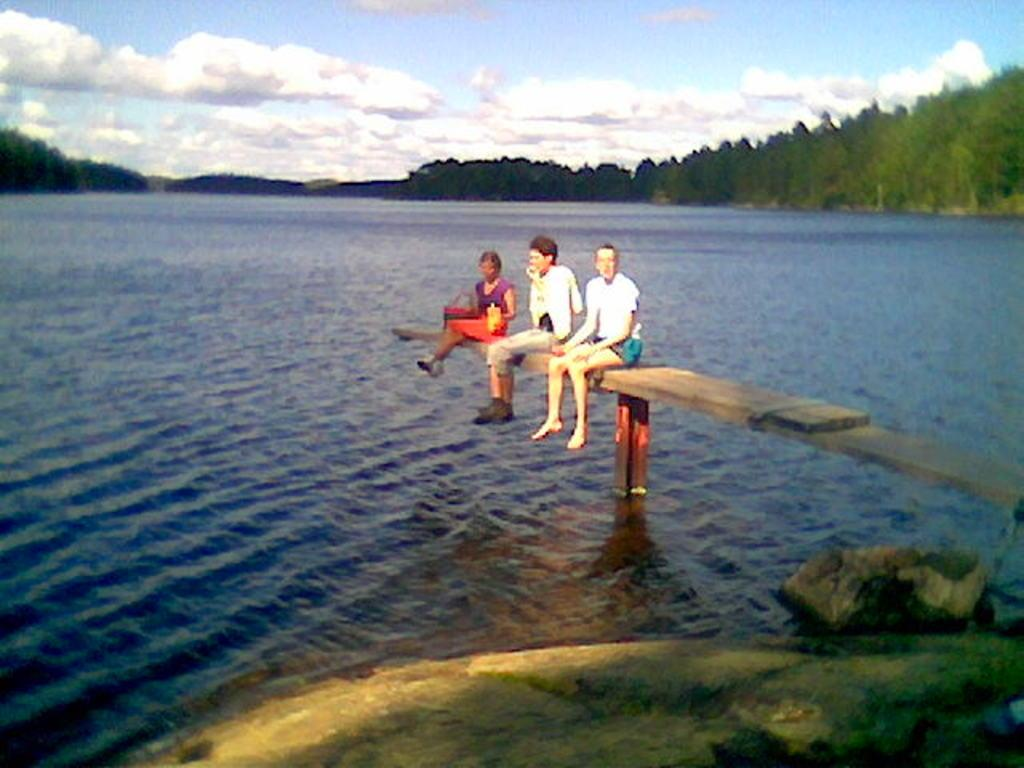How many people are present in the image? There are three people in the image. What are the people sitting on? The people are sitting on a wooden surface. What are the people holding in their hands? The people are holding food items in their hands. What natural feature can be seen in the image? There is a sea visible in the image. What type of vegetation is present in the image? There are many trees in the image. What type of marble is present in the image? There is no marble present in the image. 